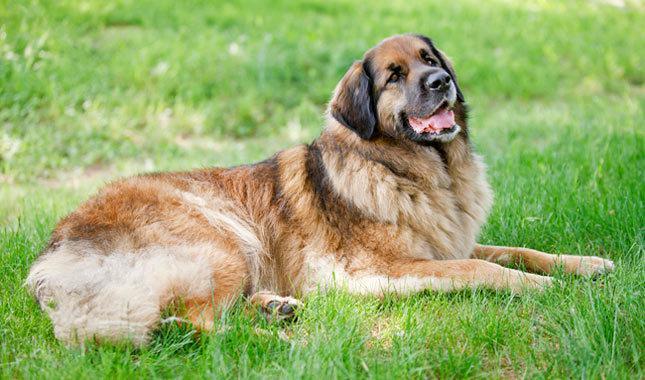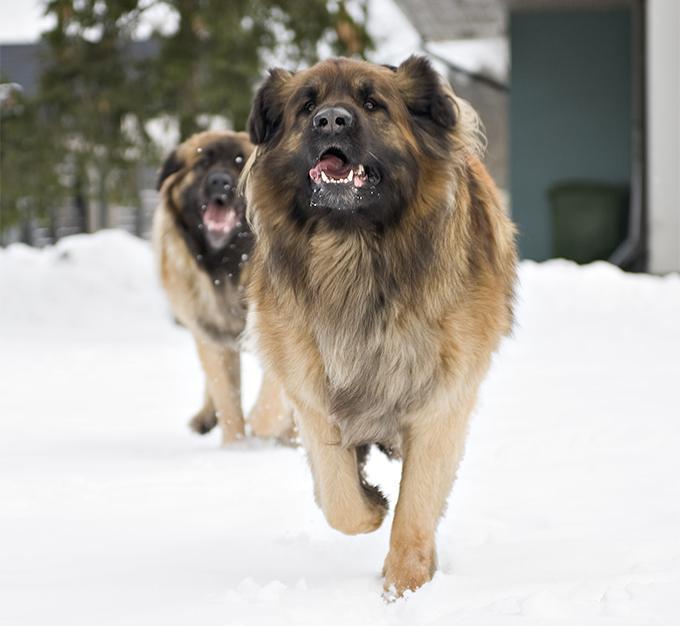The first image is the image on the left, the second image is the image on the right. For the images shown, is this caption "The sky can be seen behind the dog in the image on the left." true? Answer yes or no. No. 